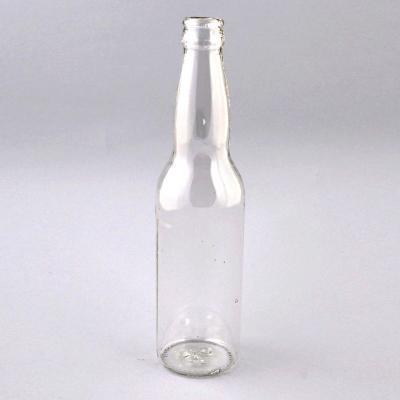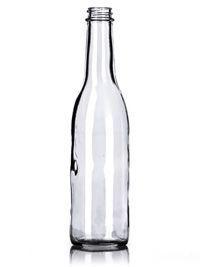The first image is the image on the left, the second image is the image on the right. Analyze the images presented: Is the assertion "The left image contains a single glass bottle with no label on its bottom half, and the right image contains at least three glass bottles with no labels." valid? Answer yes or no. No. The first image is the image on the left, the second image is the image on the right. Given the left and right images, does the statement "There are two bottles" hold true? Answer yes or no. Yes. 